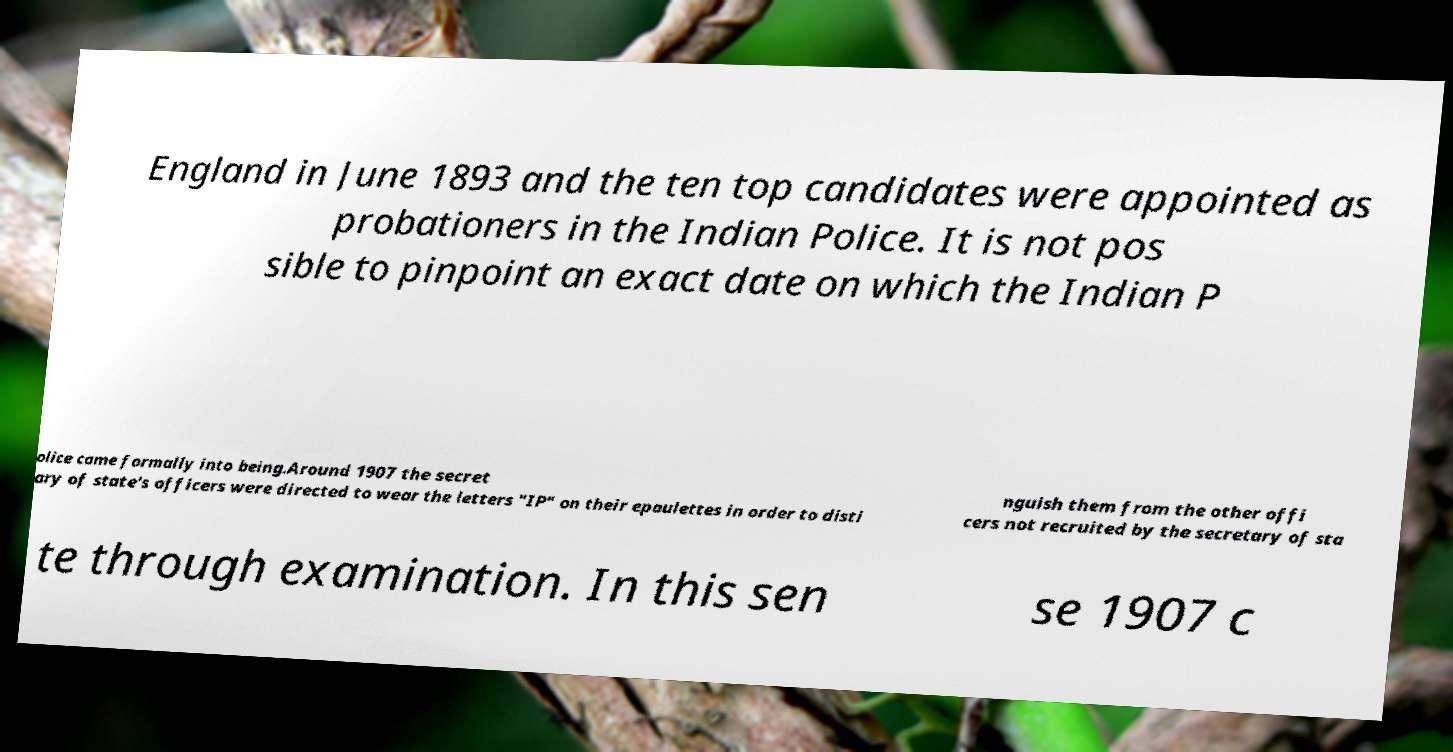I need the written content from this picture converted into text. Can you do that? England in June 1893 and the ten top candidates were appointed as probationers in the Indian Police. It is not pos sible to pinpoint an exact date on which the Indian P olice came formally into being.Around 1907 the secret ary of state's officers were directed to wear the letters "IP" on their epaulettes in order to disti nguish them from the other offi cers not recruited by the secretary of sta te through examination. In this sen se 1907 c 